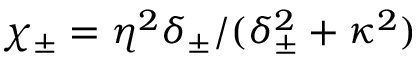<formula> <loc_0><loc_0><loc_500><loc_500>\chi _ { \pm } = \eta ^ { 2 } \delta _ { \pm } / ( \delta _ { \pm } ^ { 2 } + \kappa ^ { 2 } )</formula> 